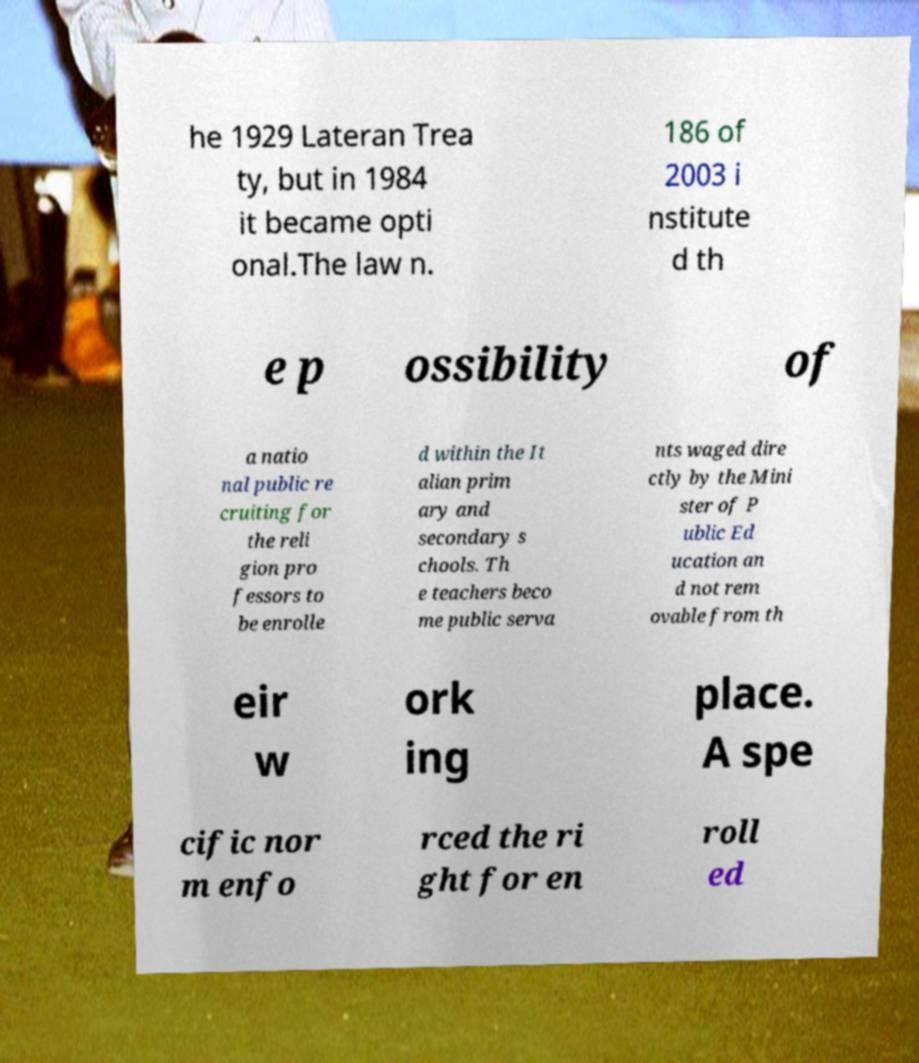What messages or text are displayed in this image? I need them in a readable, typed format. he 1929 Lateran Trea ty, but in 1984 it became opti onal.The law n. 186 of 2003 i nstitute d th e p ossibility of a natio nal public re cruiting for the reli gion pro fessors to be enrolle d within the It alian prim ary and secondary s chools. Th e teachers beco me public serva nts waged dire ctly by the Mini ster of P ublic Ed ucation an d not rem ovable from th eir w ork ing place. A spe cific nor m enfo rced the ri ght for en roll ed 